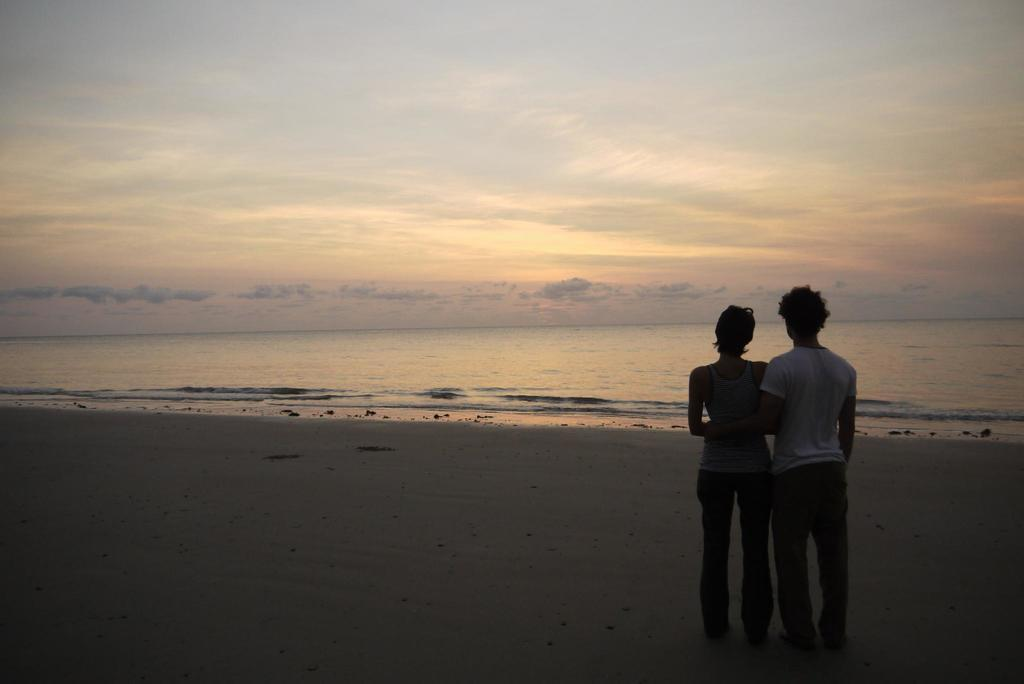What can be seen in the front of the image? There are persons standing in the front of the image. What is the main feature in the center of the image? There is an ocean in the center of the image. How would you describe the sky in the image? The sky is cloudy in the image. What type of stocking is being used by the persons in the image? There is no mention of stockings in the image, so it cannot be determined if any are being used. How does the ocean move in the image? The ocean is a large body of water and does not move in the image; it is a still representation. 